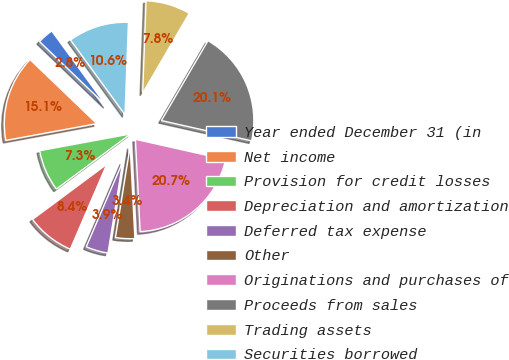Convert chart. <chart><loc_0><loc_0><loc_500><loc_500><pie_chart><fcel>Year ended December 31 (in<fcel>Net income<fcel>Provision for credit losses<fcel>Depreciation and amortization<fcel>Deferred tax expense<fcel>Other<fcel>Originations and purchases of<fcel>Proceeds from sales<fcel>Trading assets<fcel>Securities borrowed<nl><fcel>2.8%<fcel>15.08%<fcel>7.26%<fcel>8.38%<fcel>3.91%<fcel>3.36%<fcel>20.66%<fcel>20.11%<fcel>7.82%<fcel>10.61%<nl></chart> 